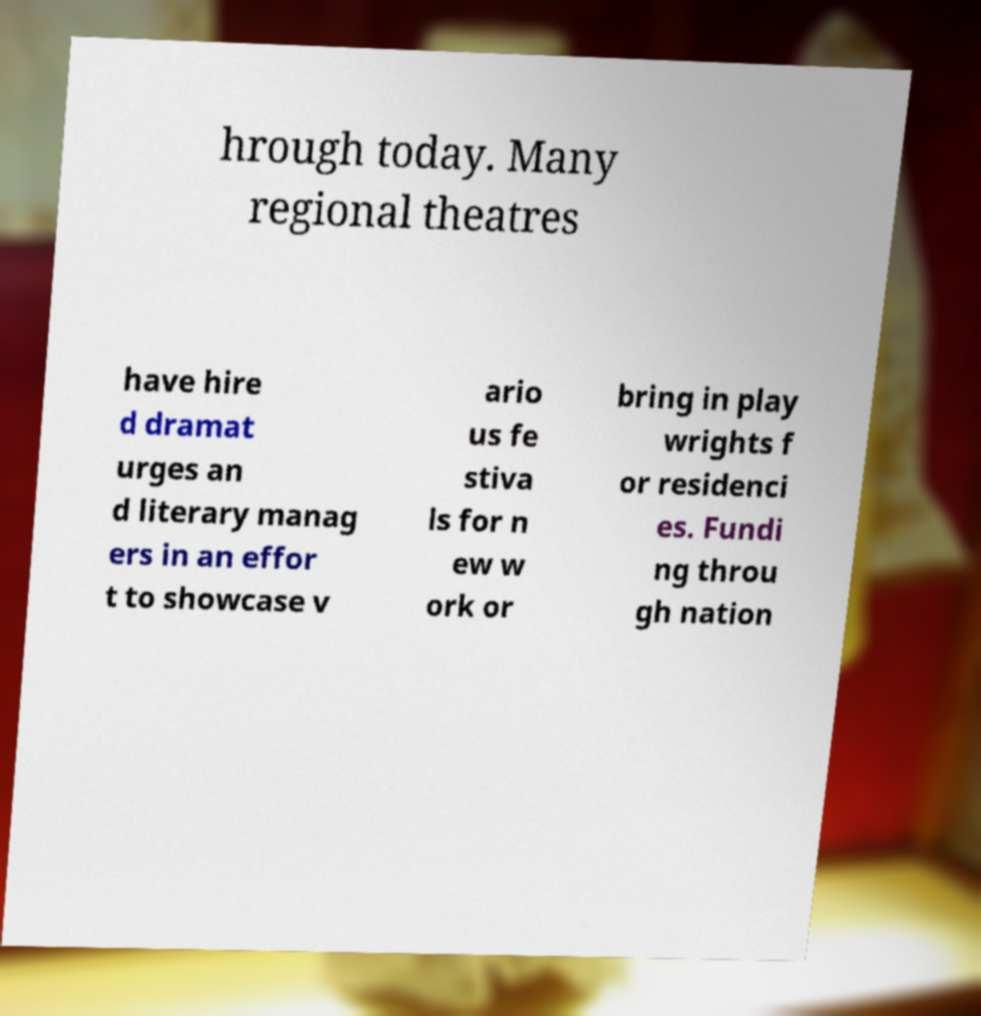Could you extract and type out the text from this image? hrough today. Many regional theatres have hire d dramat urges an d literary manag ers in an effor t to showcase v ario us fe stiva ls for n ew w ork or bring in play wrights f or residenci es. Fundi ng throu gh nation 